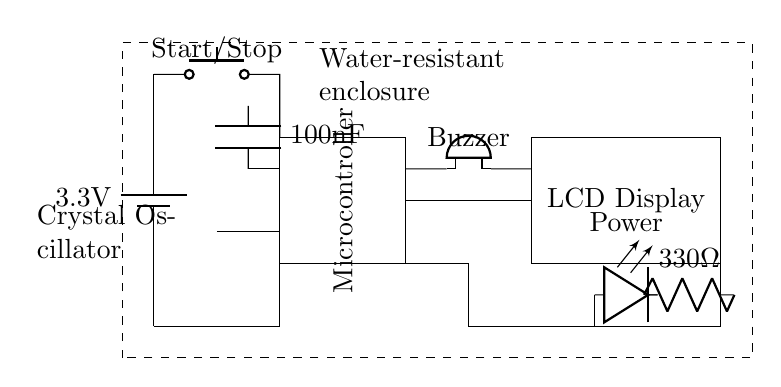What is the voltage of the power supply? The voltage of the power supply is indicated next to the battery symbol. It reads 3.3V, which is the intended voltage for the circuit.
Answer: 3.3V What type of display is present in the circuit? The type of display present is indicated in the rectangle labeled next to the connections. It states "LCD Display," indicating that it is a liquid crystal display.
Answer: LCD Display How many push buttons are in the circuit? The circuit diagram shows a single push button labeled "Start/Stop," implying there is only one push button for user interaction.
Answer: One What component is used for timekeeping in this circuit? The component used for timekeeping is a crystal oscillator, which is shown on the left and is essential for providing stable timing signals to the microcontroller.
Answer: Crystal Oscillator What is the purpose of the buzzer in this circuit? The buzzer in this circuit acts as an alert system, likely to signal the end of intervals or provide feedback to the user. Its presence is indicated by the labeled connection to the microcontroller.
Answer: Alert system How many resistors are in the circuit? The circuit diagram shows one resistor labeled as 330 Ohms, which is used in connection with the power LED to limit the current.
Answer: One What is the enclosure type for this circuit? The circuit is housed in a water-resistant enclosure, as denoted by the dashed rectangle surrounding the circuit components. This is important for protecting the electronics during rowing activities.
Answer: Water-resistant enclosure 